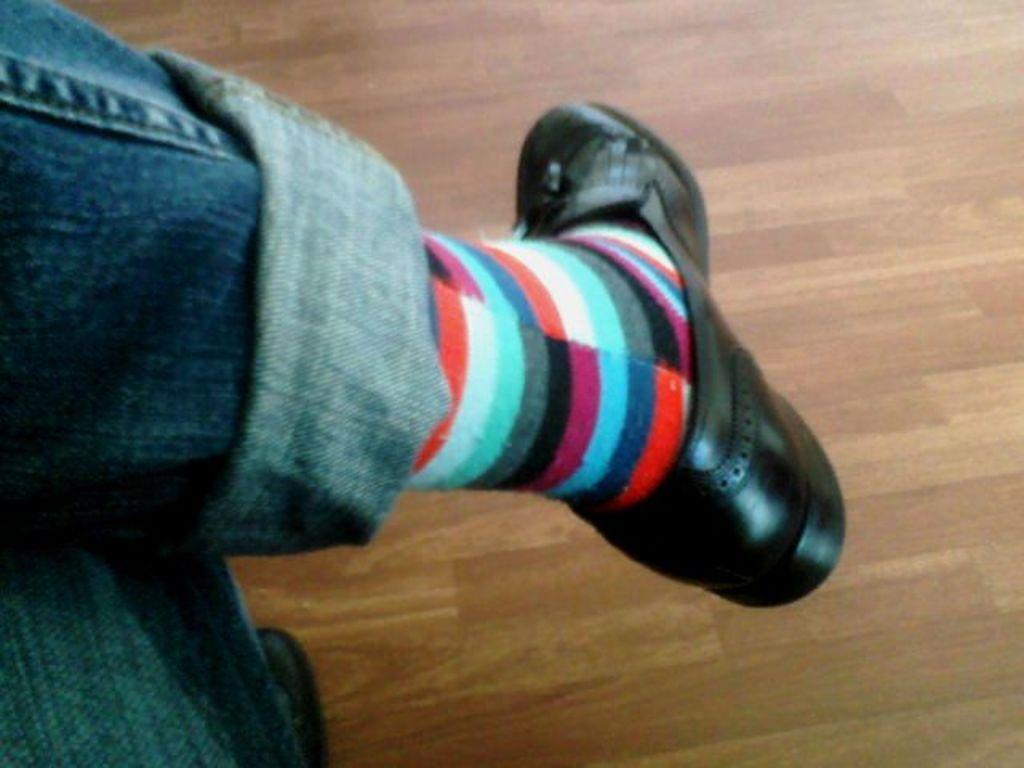Describe this image in one or two sentences. In this picture I can see a person's legs and I can see the floor. 